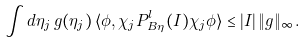<formula> <loc_0><loc_0><loc_500><loc_500>\int d \eta _ { j } \, g ( \eta _ { j } ) \, \langle \phi , \chi _ { j } P _ { B _ { \L } \eta _ { \L } } ^ { l } ( I ) \chi _ { j } \phi \rangle \leq | I | \, \| g \| _ { \infty } .</formula> 